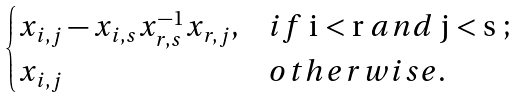Convert formula to latex. <formula><loc_0><loc_0><loc_500><loc_500>\begin{cases} x _ { i , j } - x _ { i , s } x _ { r , s } ^ { - 1 } x _ { r , j } , & i f $ i < r $ a n d $ j < s $ ; \\ x _ { i , j } & o t h e r w i s e . \end{cases}</formula> 